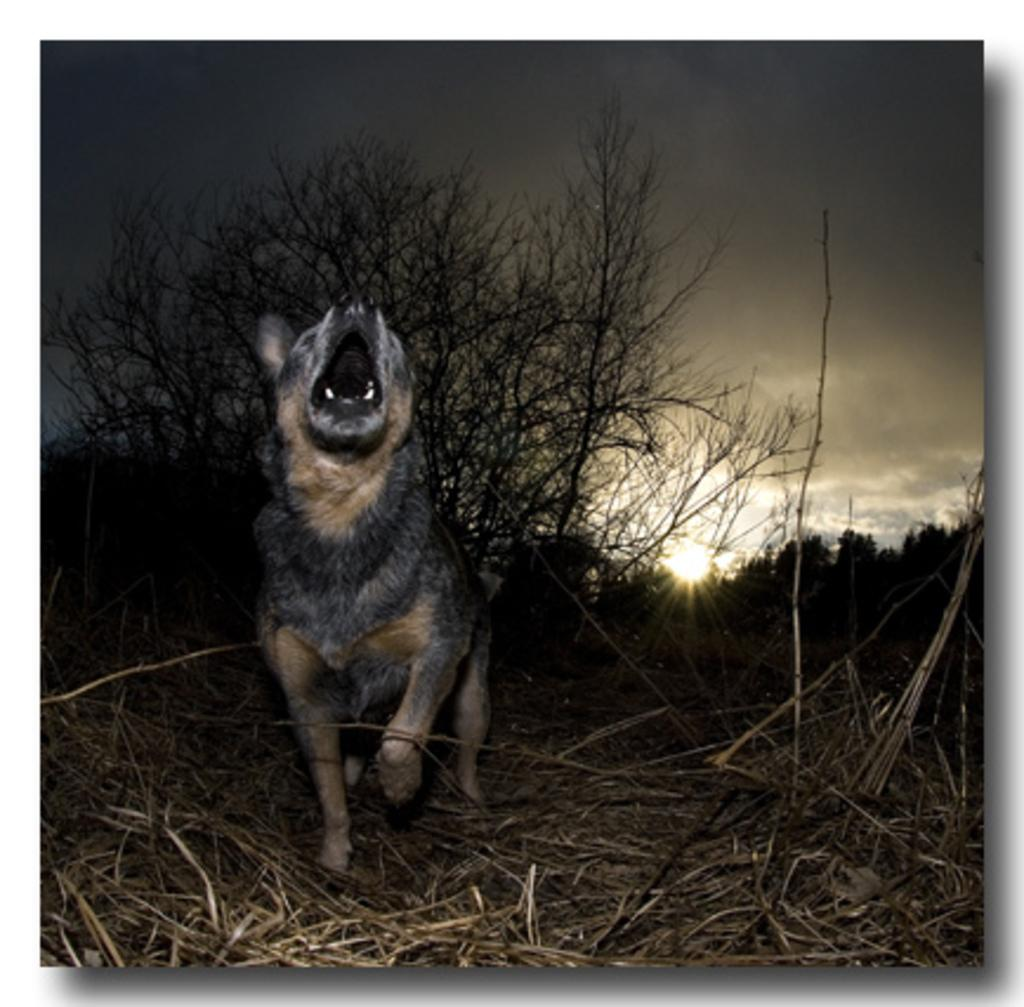What type of animal is present in the image? There is an animal in the image. What type of vegetation can be seen in the image? There is dried grass in the image. What can be seen in the background of the image? There are trees, clouds, and the sun visible in the background of the image. What type of border is present around the image? There is no border present around the image; the focus is on the animal and its surroundings. 